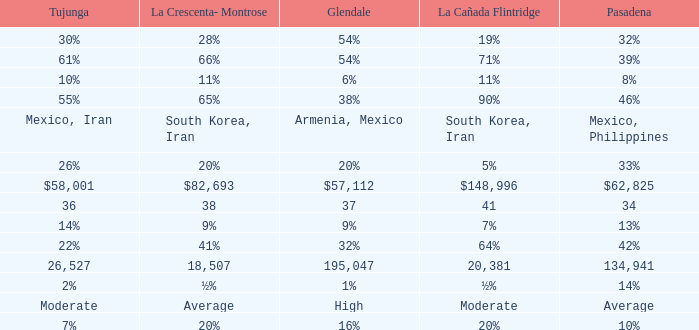When Pasadena is at 10%, what is La Crescenta-Montrose? 20%. 